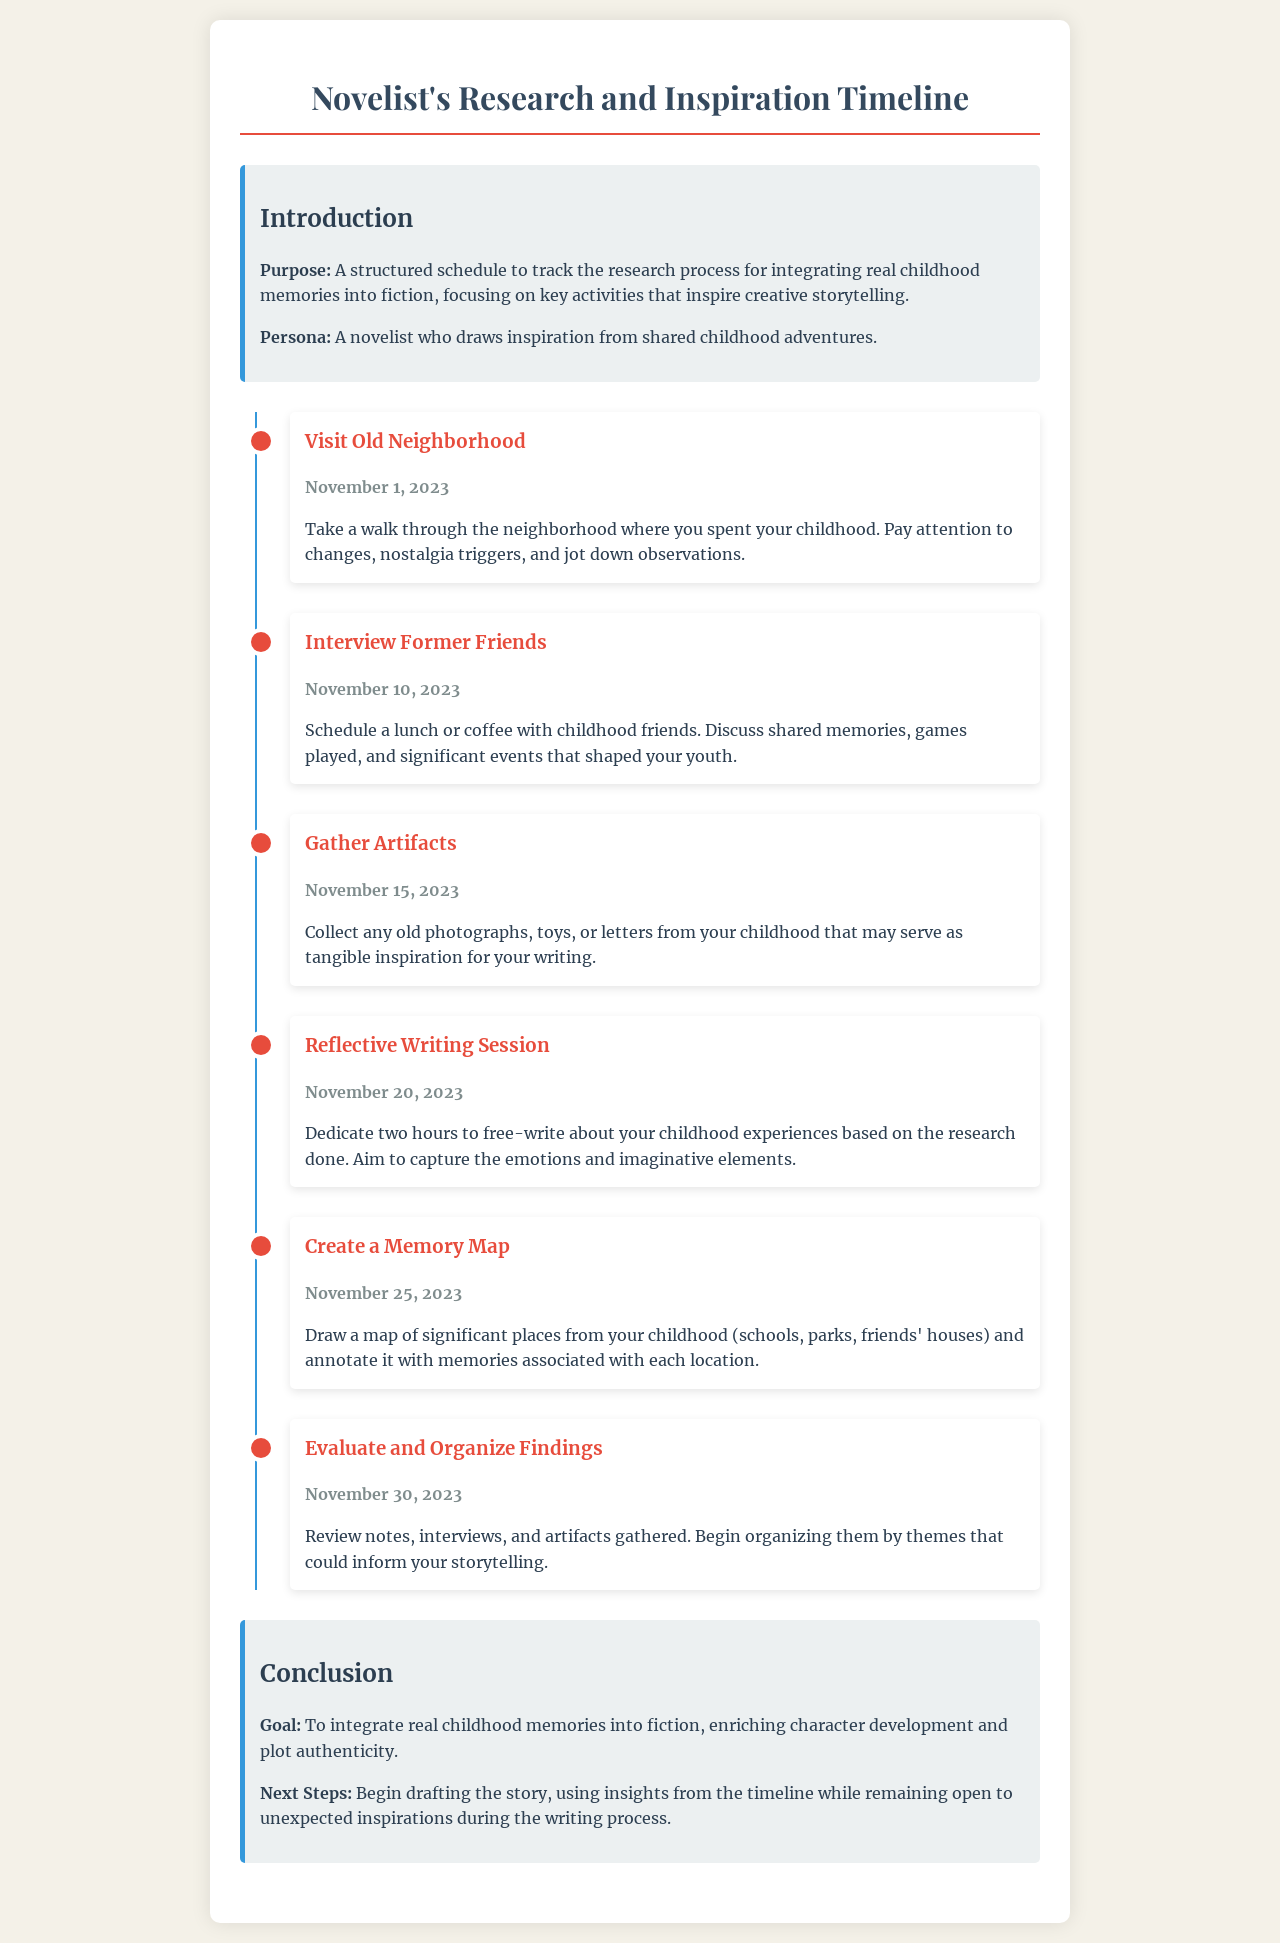What is the purpose of the document? The purpose is to provide a structured schedule to track the research process for integrating real childhood memories into fiction.
Answer: structured schedule When is the milestone to interview former friends? The document specifies the date for this milestone as outlined in the timeline.
Answer: November 10, 2023 What activity is planned for November 25, 2023? This date has a specific activity aimed at integrating childhood memories into fiction as per the timeline.
Answer: Create a Memory Map What should be gathered by November 15, 2023? This refers to a specific action related to tangible items relevant to the research process.
Answer: Artifacts What is the goal stated in the conclusion? The document outlines a specific aim regarding storytelling and character development in fiction.
Answer: integrate real childhood memories into fiction What type of writing session is scheduled on November 20, 2023? This activity type is critical for reflecting on childhood experiences as highlighted in the timeline.
Answer: Reflective Writing Session What is the concluding action step after the evaluation on November 30, 2023? This outlines what should come next in the writing process following analysis of collected materials.
Answer: Begin drafting the story How many hours are dedicated to the reflective writing session? This is a specific detail regarding time management for this activity mentioned in the schedule.
Answer: two hours 